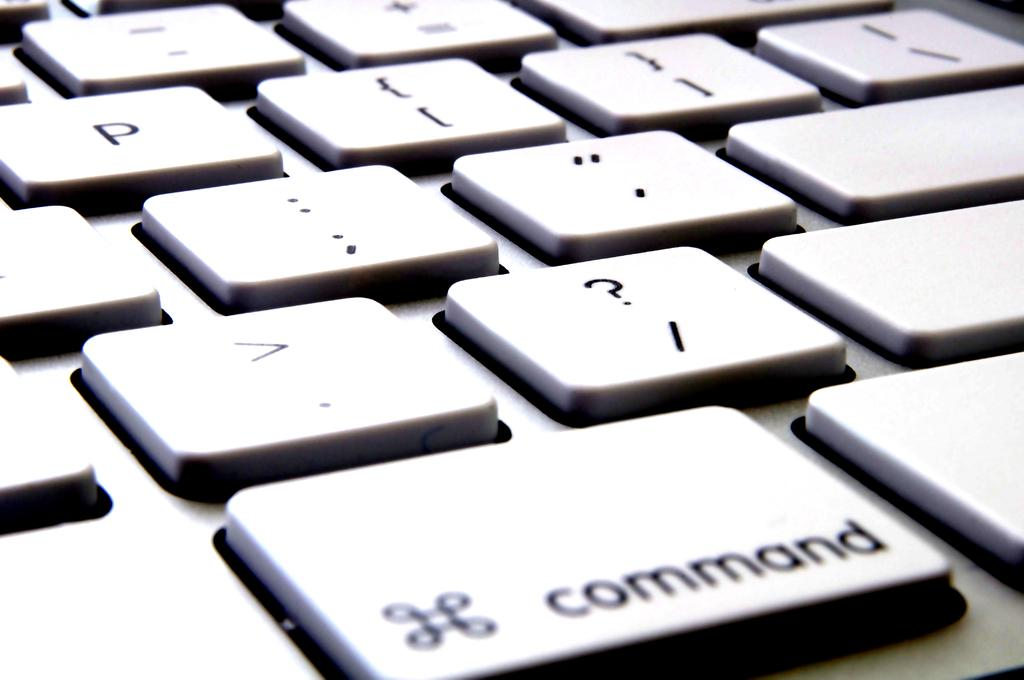<image>
Share a concise interpretation of the image provided. Laptop keyboard keys with the command key under the period key. 